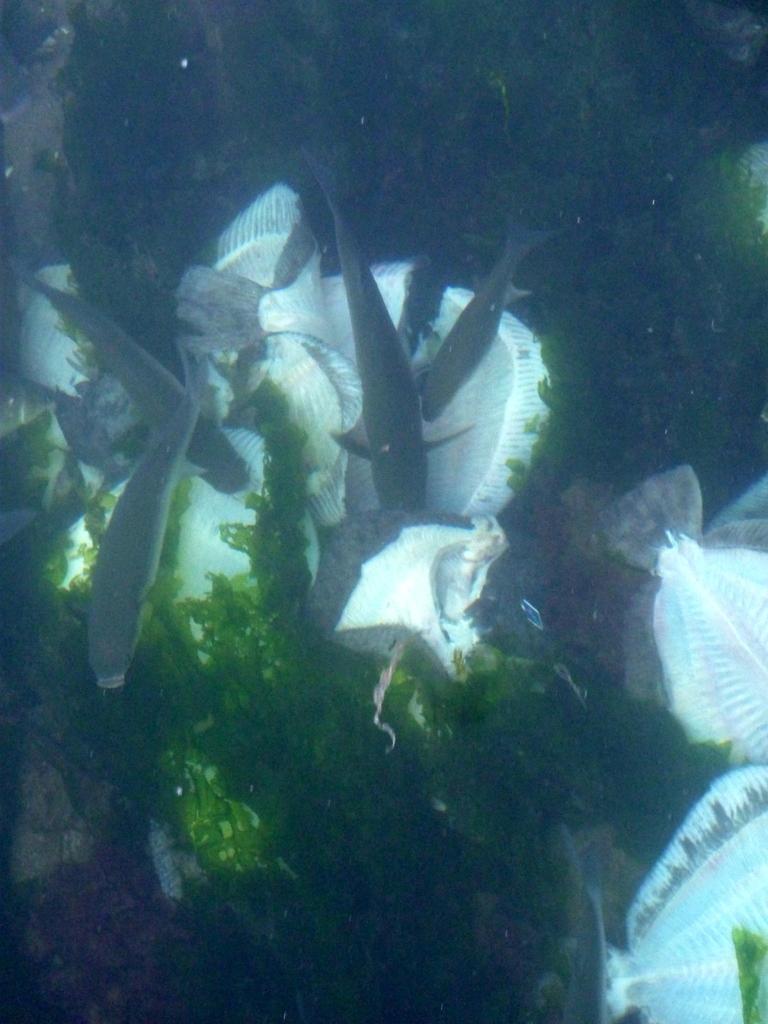How would you summarize this image in a sentence or two? Here we can see an underwater environment, in this picture we can see some plants and fishes. 